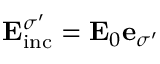<formula> <loc_0><loc_0><loc_500><loc_500>E _ { i n c } ^ { \sigma ^ { \prime } } = E _ { 0 } e _ { \sigma ^ { \prime } }</formula> 